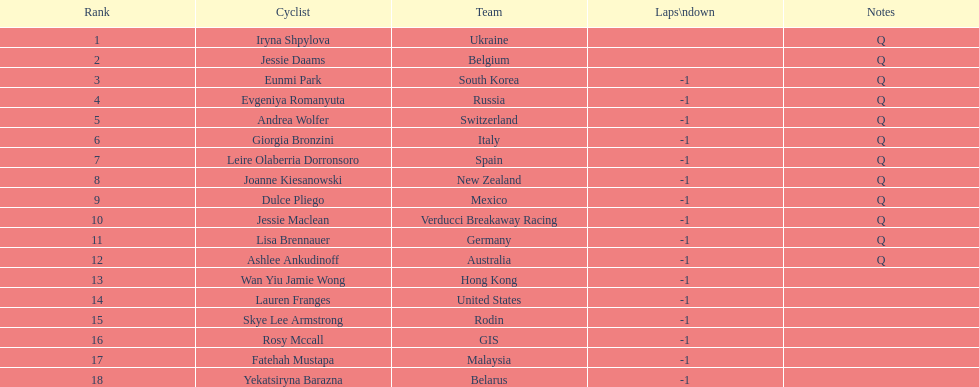What is the number rank of belgium? 2. 